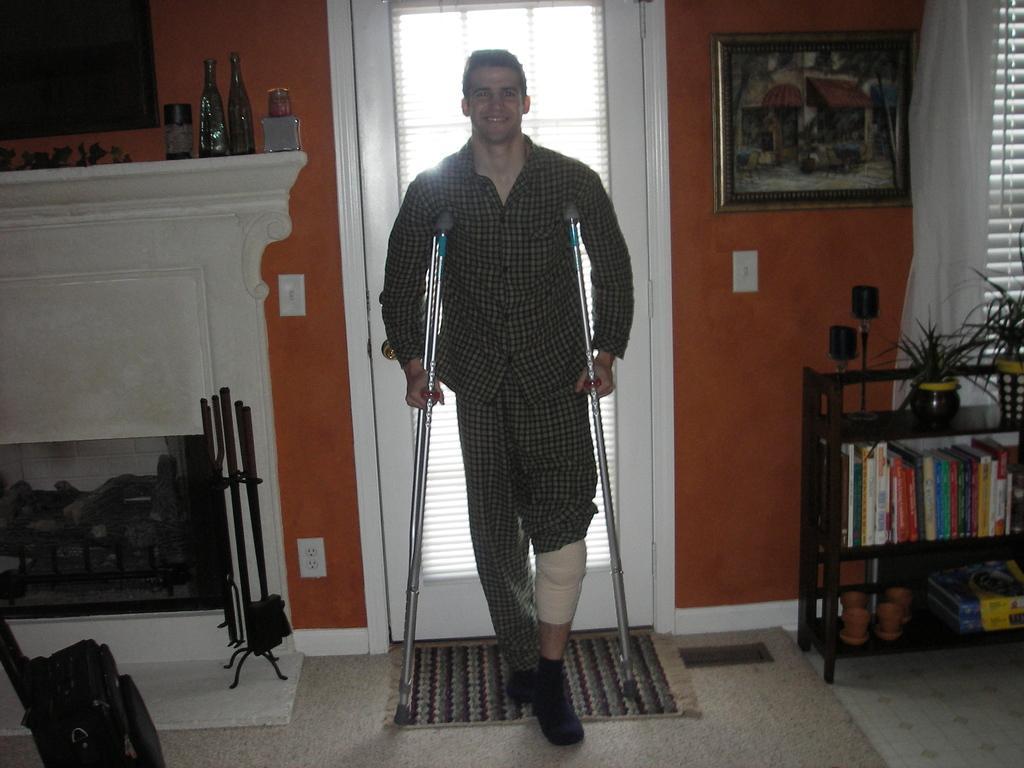Please provide a concise description of this image. In this picture we can see a person holding walking sticks in his hands and smiling. There is a bag, stand and a few objects are visible on the left side. We can see some vases on the shelf. There are books, house plants and other objects are visible on a black stand. We can see a frame and other objects are visible on the walls. There are window shades. We can see a doormat on the ground. 